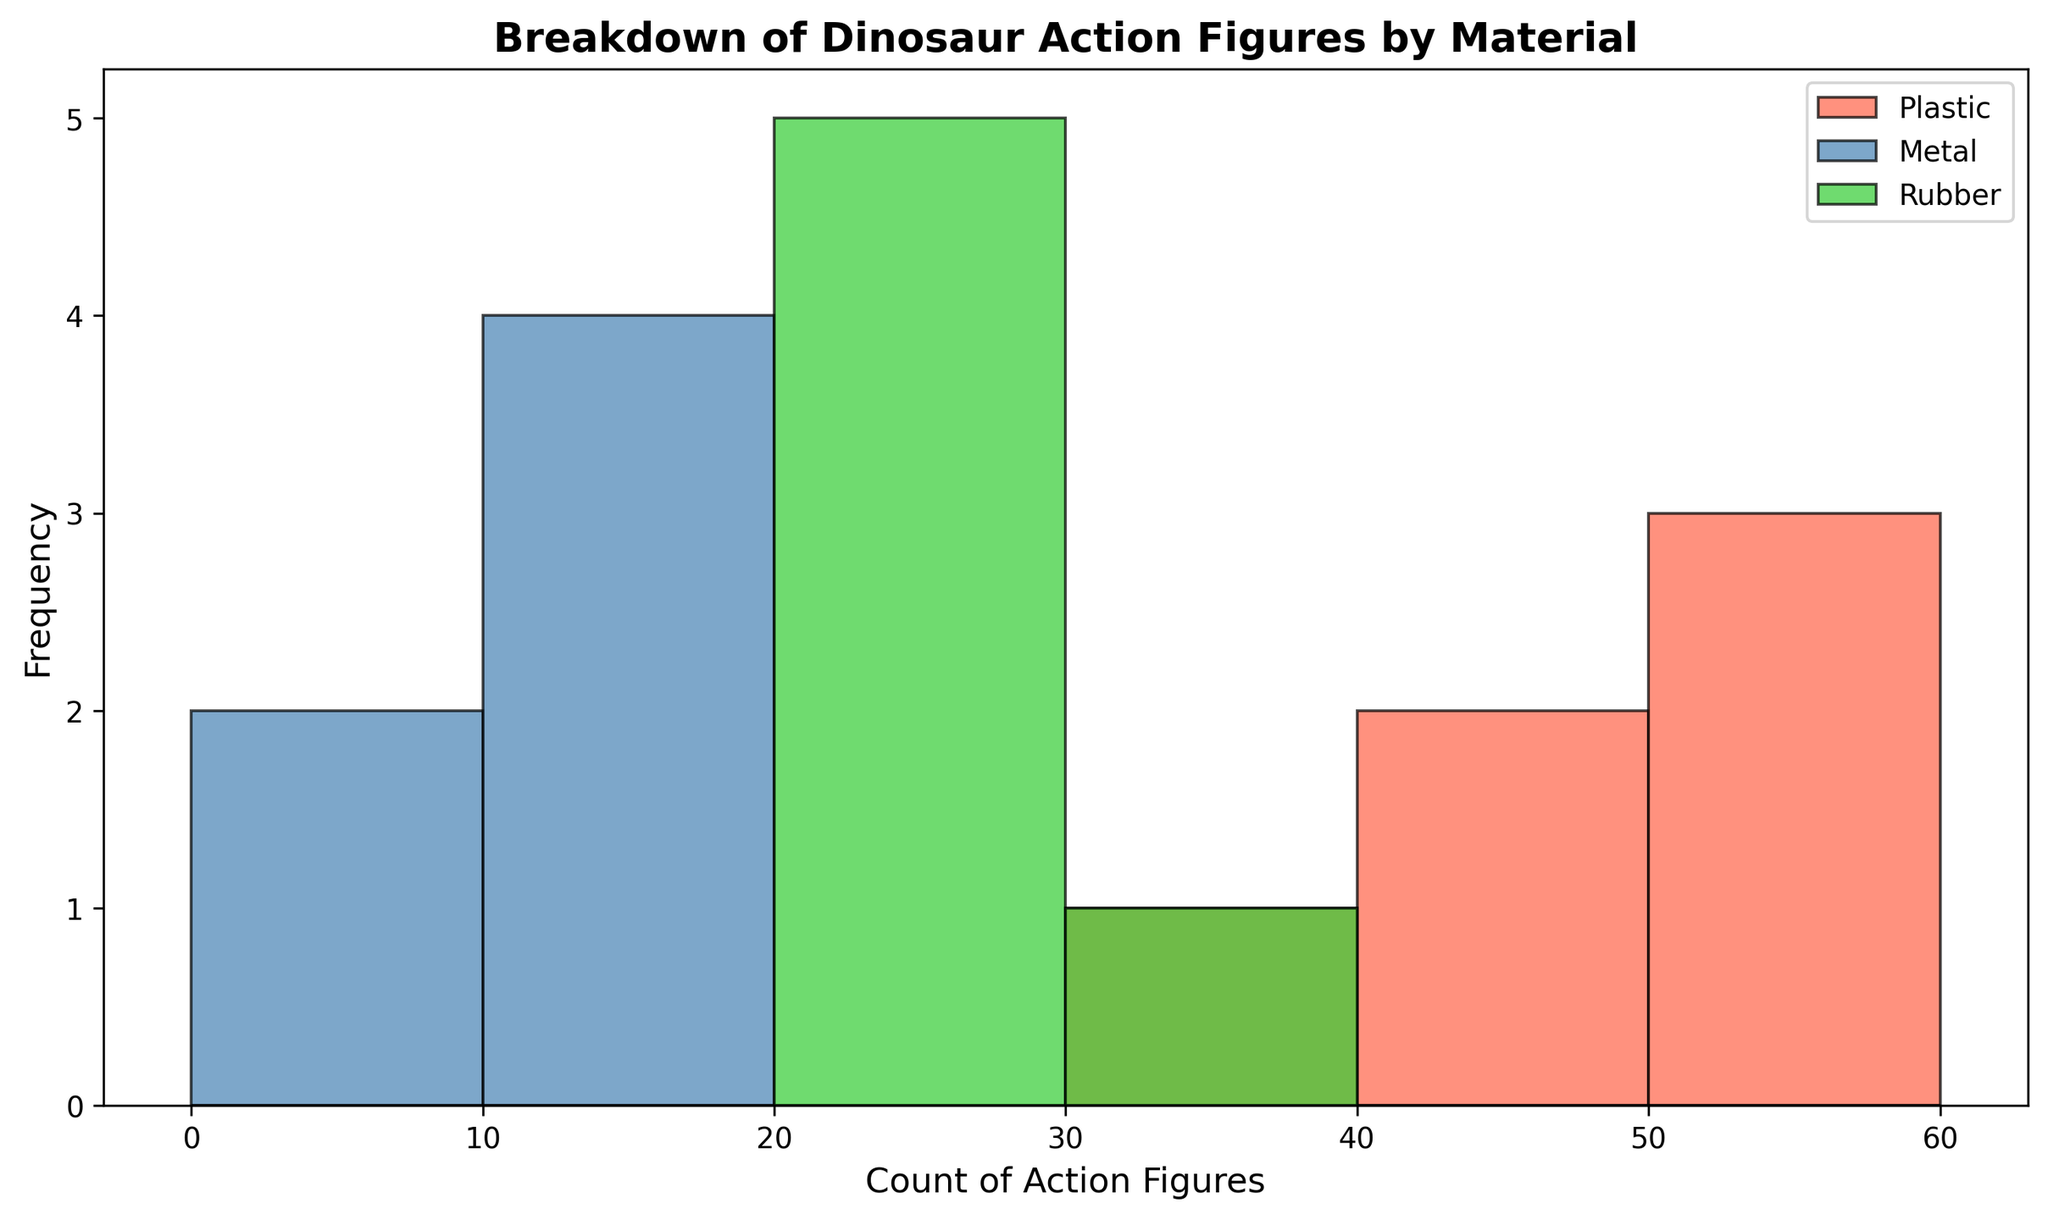How many total action figures are made of Plastic? First, add up all the Plastic action figures counts: 35 + 45 + 50 + 40 + 60 + 55 = 285
Answer: 285 Which material has the highest frequency in the 20-30 action figure count range? Look at the histograms in the 20-30 range and compare the height of the bars. Rubber has the tallest bar.
Answer: Rubber What is the combined count of Rubber and Metal action figures in the 15-25 range? Add counts from the histograms in the 15-25 range for Rubber (30 + 25 + 22 + 28 + 24) and Metal (15 + 12 + 14 + 9): 30 + 25 + 22 + 28 + 24 + 15 + 12 + 14 + 9 = 179
Answer: 179 How does the most common count of Plastic figures compare to that of Rubber? Identify the tallest bars for each material. For Plastic, the most common count is at 50-60. For Rubber, it is at 20-30. Plastic's bar is taller, indicating a higher count frequency in its most common range compared to Rubber.
Answer: Plastic has a higher count frequency What range has the least frequency for Metal action figures? Look for the shortest bar in the histogram for Metal. It occurs in the 0-10 range.
Answer: 0-10 What material typically has counts in the range 50-60? Examine the histograms in the 50-60 range. Only Plastic has a histogram bar in this range.
Answer: Plastic Is there any overlap in the count ranges of Metal and Rubber action figures? Check the ranges of the histogram bars for Metal and Rubber. Both materials have bars in the 0-10 and 20-30 ranges, indicating overlaps.
Answer: Yes What is the average count of Plastic action figures across all data points? Sum all Plastic counts (35 + 45 + 50 + 40 + 60 + 55 = 285) and divide by the number of data points (6): 285 / 6 = 47.5
Answer: 47.5 In which count range do all three materials have at least one data point? Look at the histogram bars to see where all colors are present. The 20-30 range has bars for all three materials.
Answer: 20-30 